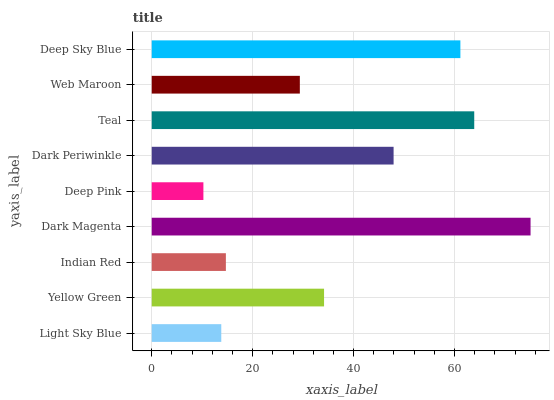Is Deep Pink the minimum?
Answer yes or no. Yes. Is Dark Magenta the maximum?
Answer yes or no. Yes. Is Yellow Green the minimum?
Answer yes or no. No. Is Yellow Green the maximum?
Answer yes or no. No. Is Yellow Green greater than Light Sky Blue?
Answer yes or no. Yes. Is Light Sky Blue less than Yellow Green?
Answer yes or no. Yes. Is Light Sky Blue greater than Yellow Green?
Answer yes or no. No. Is Yellow Green less than Light Sky Blue?
Answer yes or no. No. Is Yellow Green the high median?
Answer yes or no. Yes. Is Yellow Green the low median?
Answer yes or no. Yes. Is Deep Pink the high median?
Answer yes or no. No. Is Web Maroon the low median?
Answer yes or no. No. 